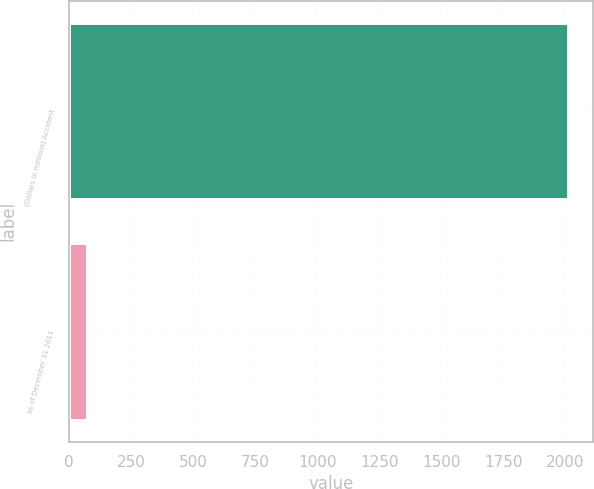<chart> <loc_0><loc_0><loc_500><loc_500><bar_chart><fcel>(Dollars in millions) Accident<fcel>as of December 31 2011<nl><fcel>2010<fcel>73.2<nl></chart> 